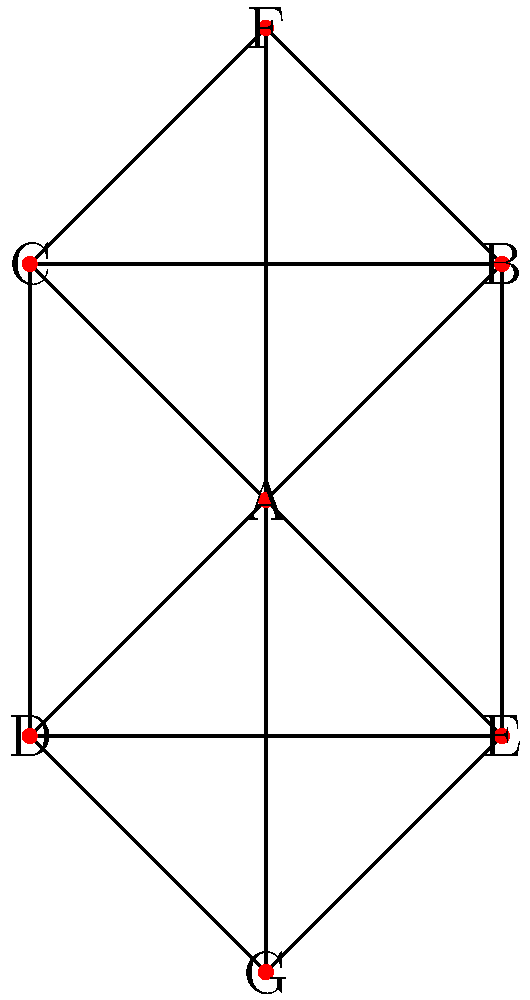In the given network diagram representing a grassroots organization, which member has the highest degree centrality and is likely to be a key figure in information dissemination? To determine the member with the highest degree centrality, we need to follow these steps:

1. Understand degree centrality: It measures the number of direct connections a node has in the network.

2. Count the connections for each node:
   A: 6 connections (to B, C, D, E, F, G)
   B: 4 connections (to A, C, E, F)
   C: 4 connections (to A, B, D, F)
   D: 4 connections (to A, C, E, G)
   E: 4 connections (to A, B, D, G)
   F: 3 connections (to A, B, C)
   G: 3 connections (to A, D, E)

3. Identify the highest degree: Node A has 6 connections, which is the highest.

4. Interpret the result: Member A has the most direct connections, making them central in the network and likely to be key in information dissemination.

Therefore, member A has the highest degree centrality and is likely to be a key figure in information dissemination within this grassroots organization.
Answer: A 